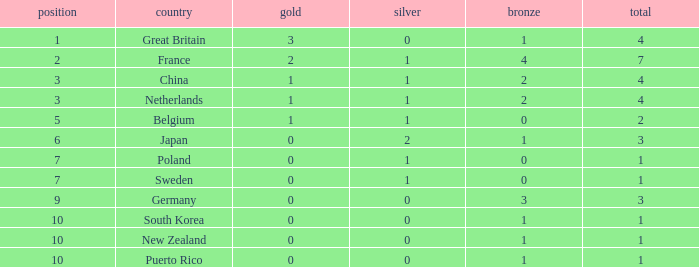What is the total where the gold is larger than 2? 1.0. 